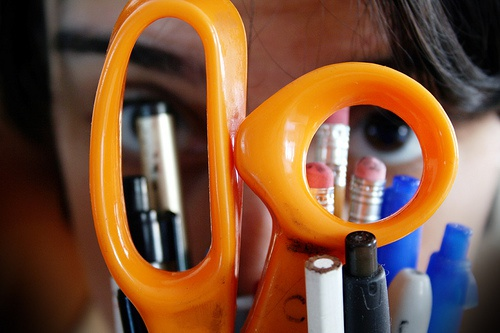Describe the objects in this image and their specific colors. I can see people in black, maroon, gray, and brown tones and scissors in black, orange, red, and maroon tones in this image. 